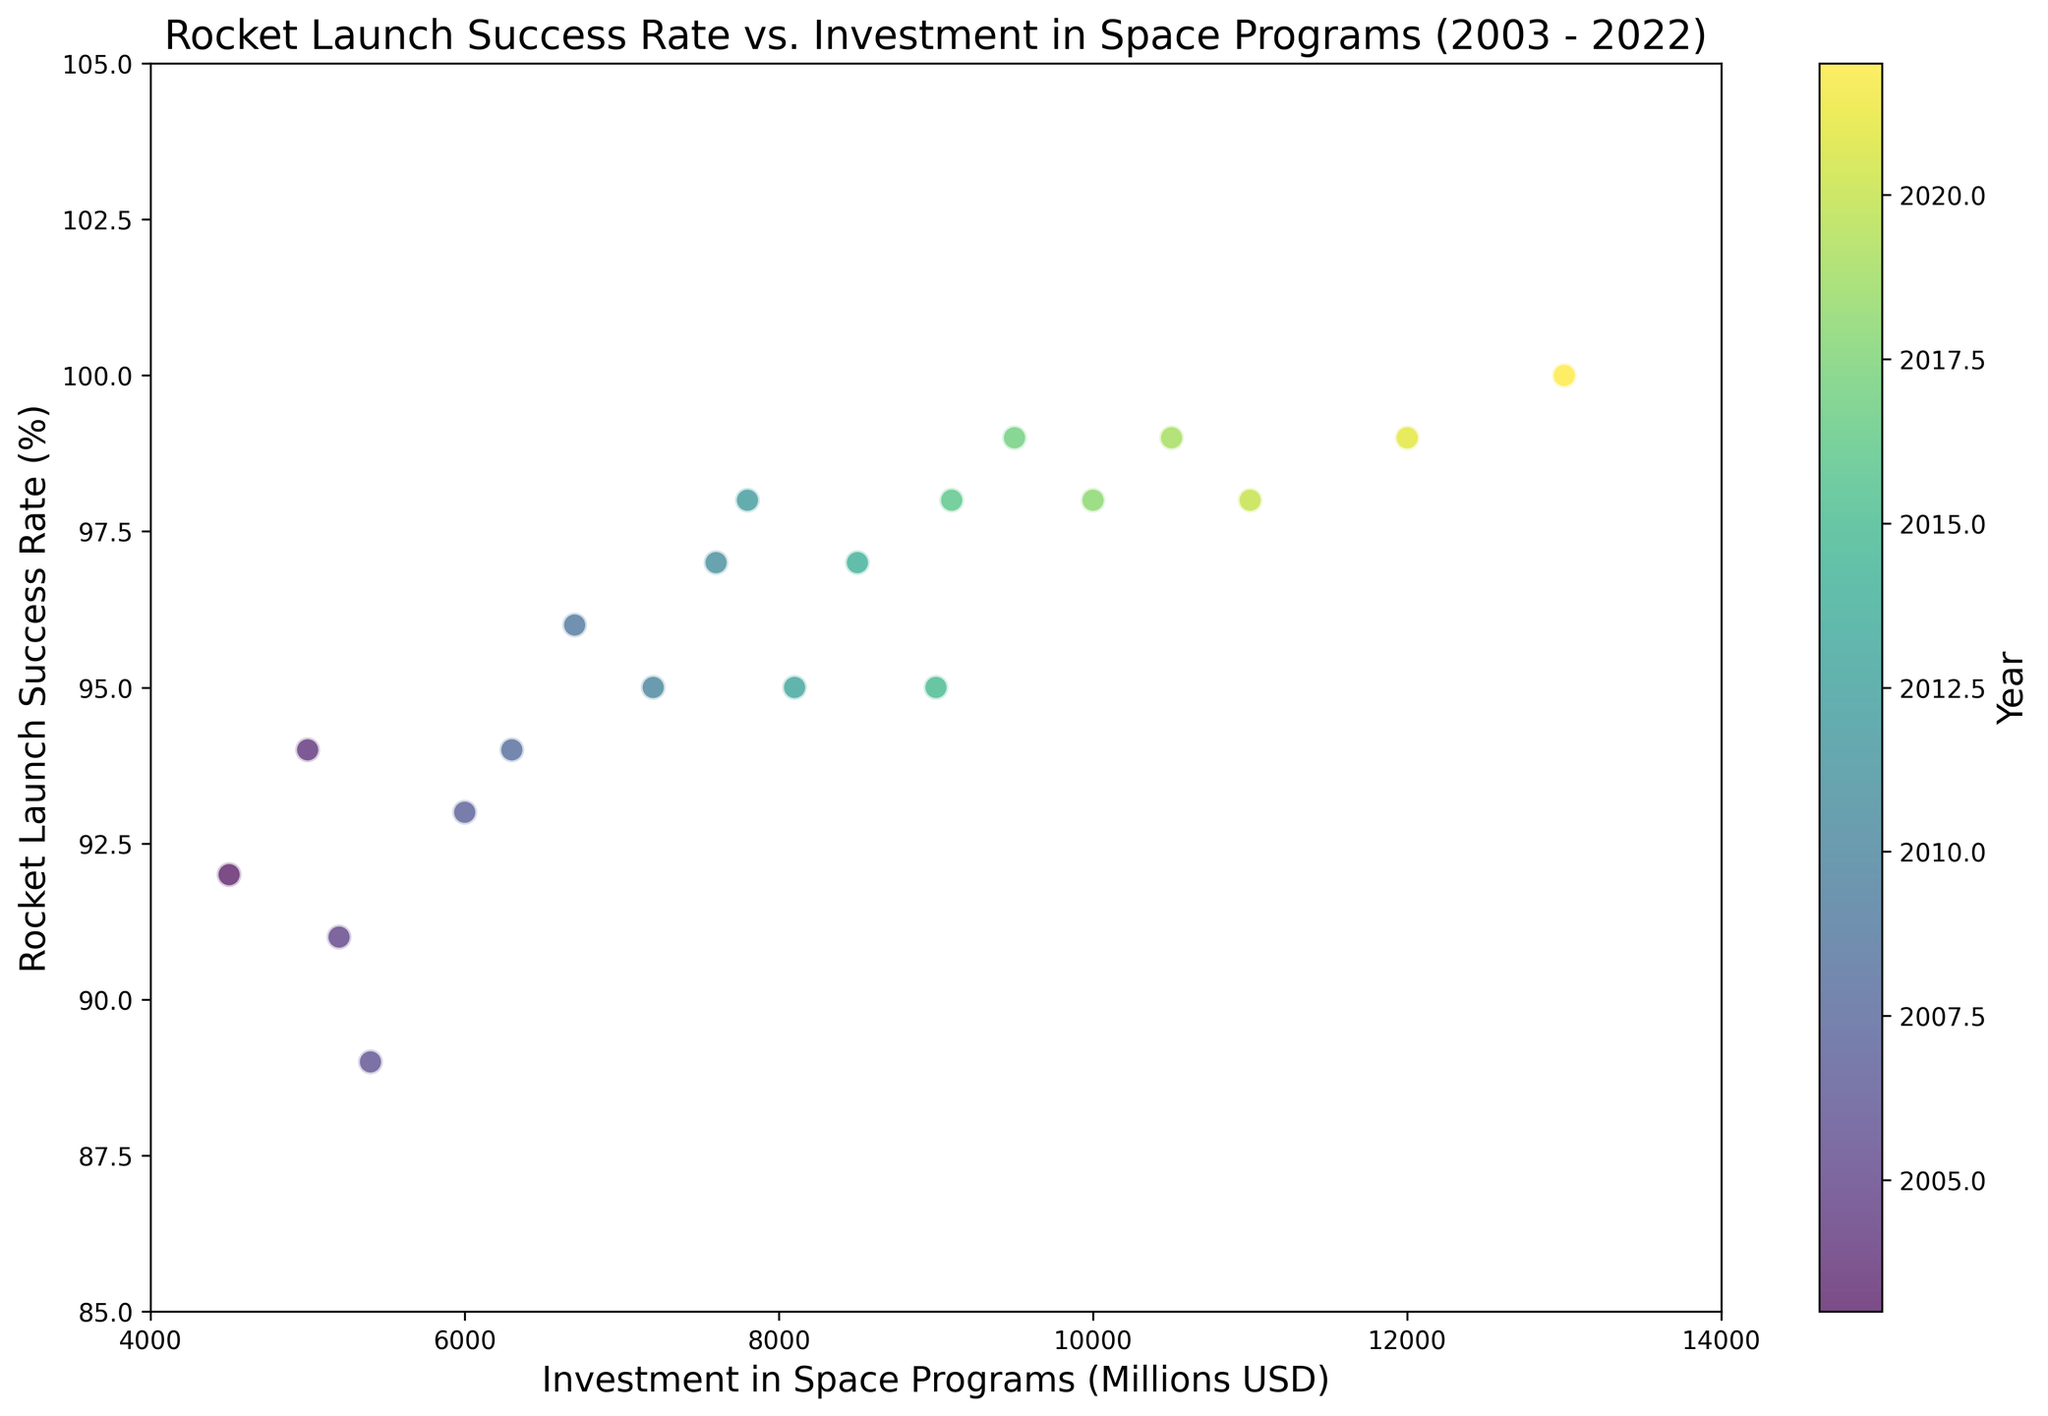What is the trend in rocket launch success rates over the last two decades? To identify the trend, observe the y-values (rocket launch success rates) over the x-axial years from 2003 to 2022. Success rates generally increase over time.
Answer: Increasing How does the investment in space programs correlate with rocket launch success rates? By comparing the two axes, higher investments usually align with higher success rates over the years, suggesting a positive correlation.
Answer: Positive correlation Between which years did the largest increase in rocket launch success rates occur? By examining the y-values over time, the largest increase is between 2011 (97%) and 2012 (98%), followed by 2016 (98%) and 2017 (99%). Calculate the difference and find the largest.
Answer: 2016-2017 What is the average investment in space programs from 2018 to 2022? Sum the investments from 2018 to 2022 and divide by the number of years: (10000 + 10500 + 11000 + 12000 + 13000) / 5 = 11300.
Answer: 11300 Which year had the highest rocket launch success rate and what was the investment that year? Observe the data points to find the highest point on the y-axis and note the corresponding x-axis value. 2022 shows the highest success rate of 100% with an investment of 13000 million USD.
Answer: 2022, 13000 Compare the rocket launch success rates in the years 2003 and 2022. What is the difference? In 2003, the success rate was 92%, and in 2022, it was 100%. The difference is 100% - 92% = 8%.
Answer: 8% Which year saw the highest year-over-year increase in investment? Calculate the year-over-year differences in investments and find the maximum difference. From 2021 to 2022, the investment increase was the highest: 13000 - 12000 = 1000 million USD.
Answer: 2021-2022 Is there any year where an increase in investment did not lead to an increase in rocket launch success rates? Compare the investment and success rate changes year by year to find anomalies where higher investments didn't correlate with an increase or even saw a decline in success rates. In 2005 (5200 million, 91%) and 2006 (5400 million, 89%), the success rate decreased despite higher investment.
Answer: 2005-2006 